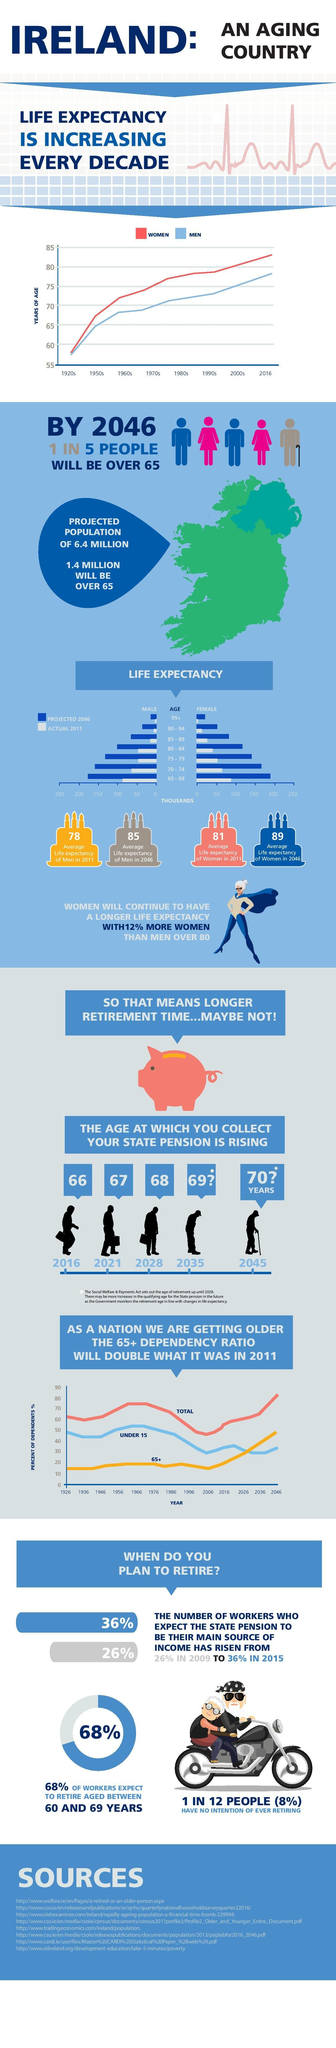Mention a couple of crucial points in this snapshot. The projected pension age in Ireland in 2028 is 68. The projected population of Ireland in 2046 is estimated to be 6.4 million. In the 1990s in Ireland, men had a lower life expectancy than women. The pension age in Ireland in 2016 was 66. In 2015, 36% of workers in Ireland expected the state pension to be their main source of income. 